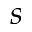<formula> <loc_0><loc_0><loc_500><loc_500>s</formula> 